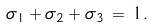<formula> <loc_0><loc_0><loc_500><loc_500>\sigma _ { 1 } + \sigma _ { 2 } + \sigma _ { 3 } \, = \, 1 .</formula> 